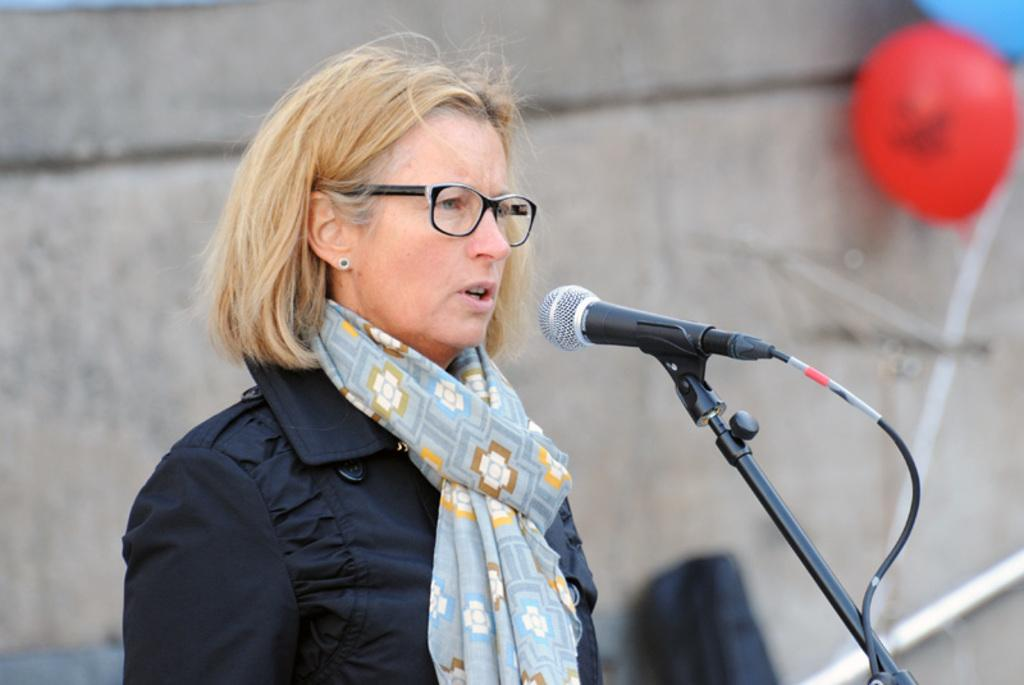Who is the main subject in the image? There is a lady in the center of the image. What accessories is the lady wearing? The lady is wearing glasses and a scarf. What is the lady holding in the image? There is a mic in front of the lady. What can be seen in the background of the image? There is a wall and balloons visible in the background. How many eggs are on the table next to the lady in the image? There are no eggs visible in the image; the focus is on the lady, her accessories, the mic, and the background elements. 